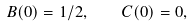Convert formula to latex. <formula><loc_0><loc_0><loc_500><loc_500>B ( 0 ) = 1 / 2 , \quad C ( 0 ) = 0 ,</formula> 